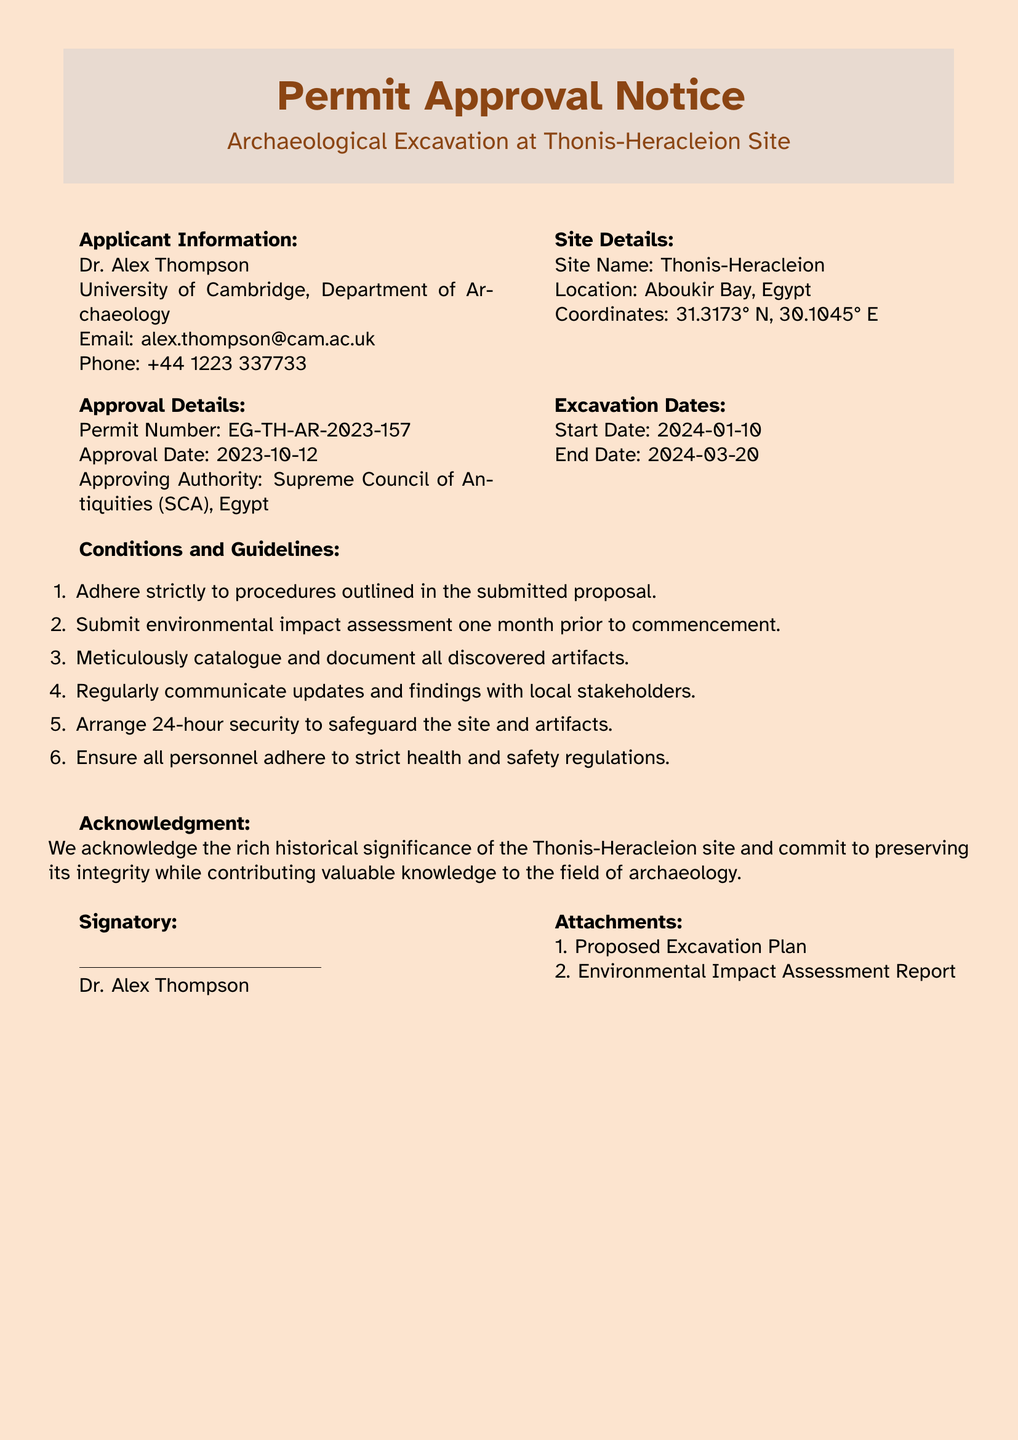What is the permit number? The permit number is listed in the approval details section of the document.
Answer: EG-TH-AR-2023-157 Who is the applicant? The applicant's name is provided in the applicant information section.
Answer: Dr. Alex Thompson Where is the Thonis-Heracleion site located? The location of the site is mentioned in the site details section.
Answer: Aboukir Bay, Egypt What are the excavation dates? The start and end dates for the excavation are specified in the excavation dates section.
Answer: 2024-01-10 to 2024-03-20 What is one condition for the excavation? The conditions for the excavation are listed in the guidelines section, which requires specific adherence.
Answer: Adhere strictly to procedures outlined in the submitted proposal How many attachments are listed? The attachments are mentioned at the end of the document, specifying their numbers.
Answer: 2 Who is the approving authority? The approving authority is identified in the approval details section of the document.
Answer: Supreme Council of Antiquities (SCA), Egypt What is required one month prior to commencement? This requirement is listed under the conditions and guidelines for the excavation.
Answer: Submit environmental impact assessment What is the email address of the applicant? The applicant's contact information includes their email.
Answer: alex.thompson@cam.ac.uk 